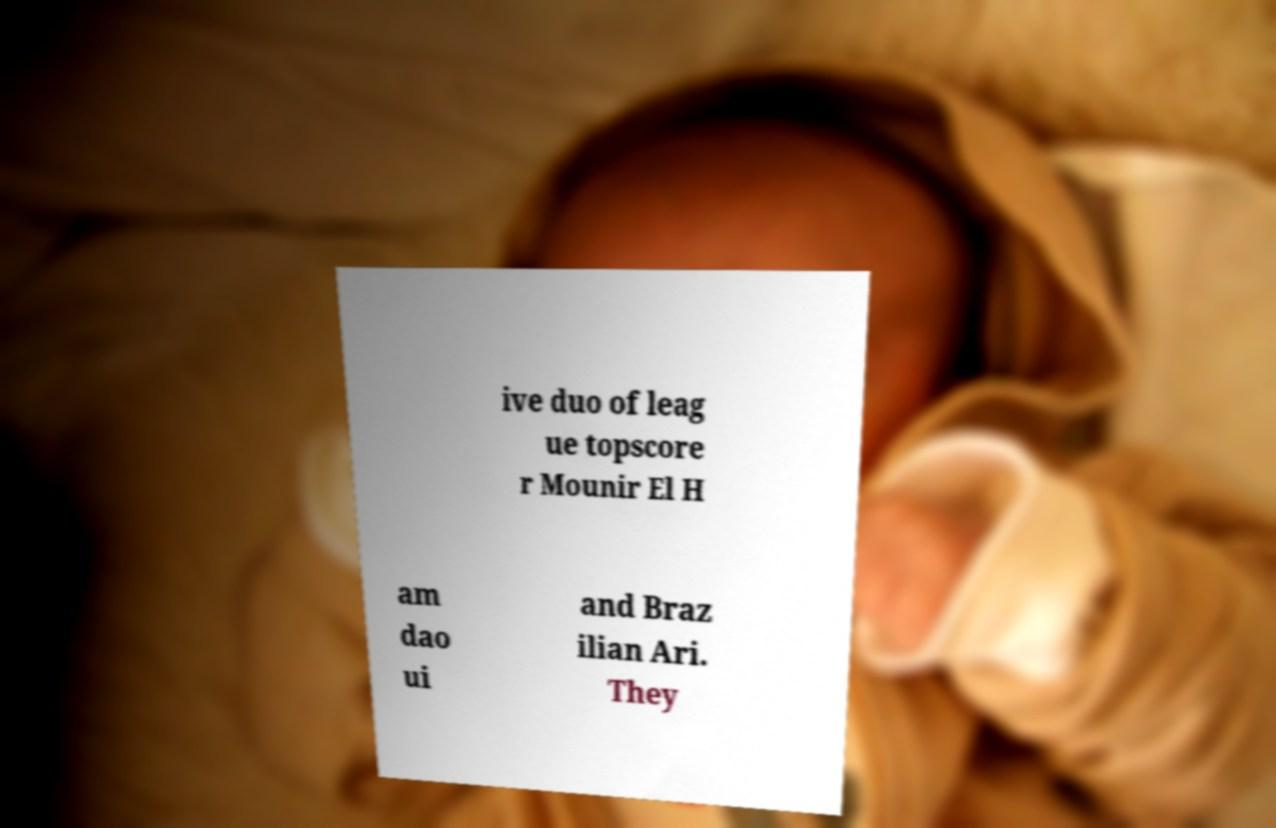Please read and relay the text visible in this image. What does it say? ive duo of leag ue topscore r Mounir El H am dao ui and Braz ilian Ari. They 